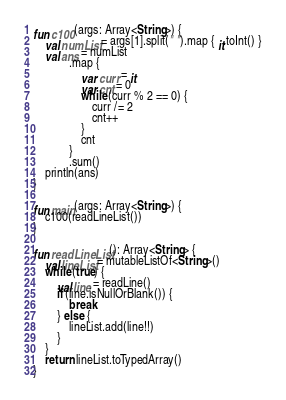<code> <loc_0><loc_0><loc_500><loc_500><_Kotlin_>fun c100(args: Array<String>) {
    val numList = args[1].split(" ").map { it.toInt() }
    val ans = numList
            .map {
                var curr = it
                var cnt = 0
                while (curr % 2 == 0) {
                    curr /= 2
                    cnt++
                }
                cnt
            }
            .sum()
    println(ans)
}

fun main(args: Array<String>) {
    c100(readLineList())
}

fun readLineList(): Array<String> {
    val lineList = mutableListOf<String>()
    while (true) {
        val line = readLine()
        if (line.isNullOrBlank()) {
            break
        } else {
            lineList.add(line!!)
        }
    }
    return lineList.toTypedArray()
}</code> 